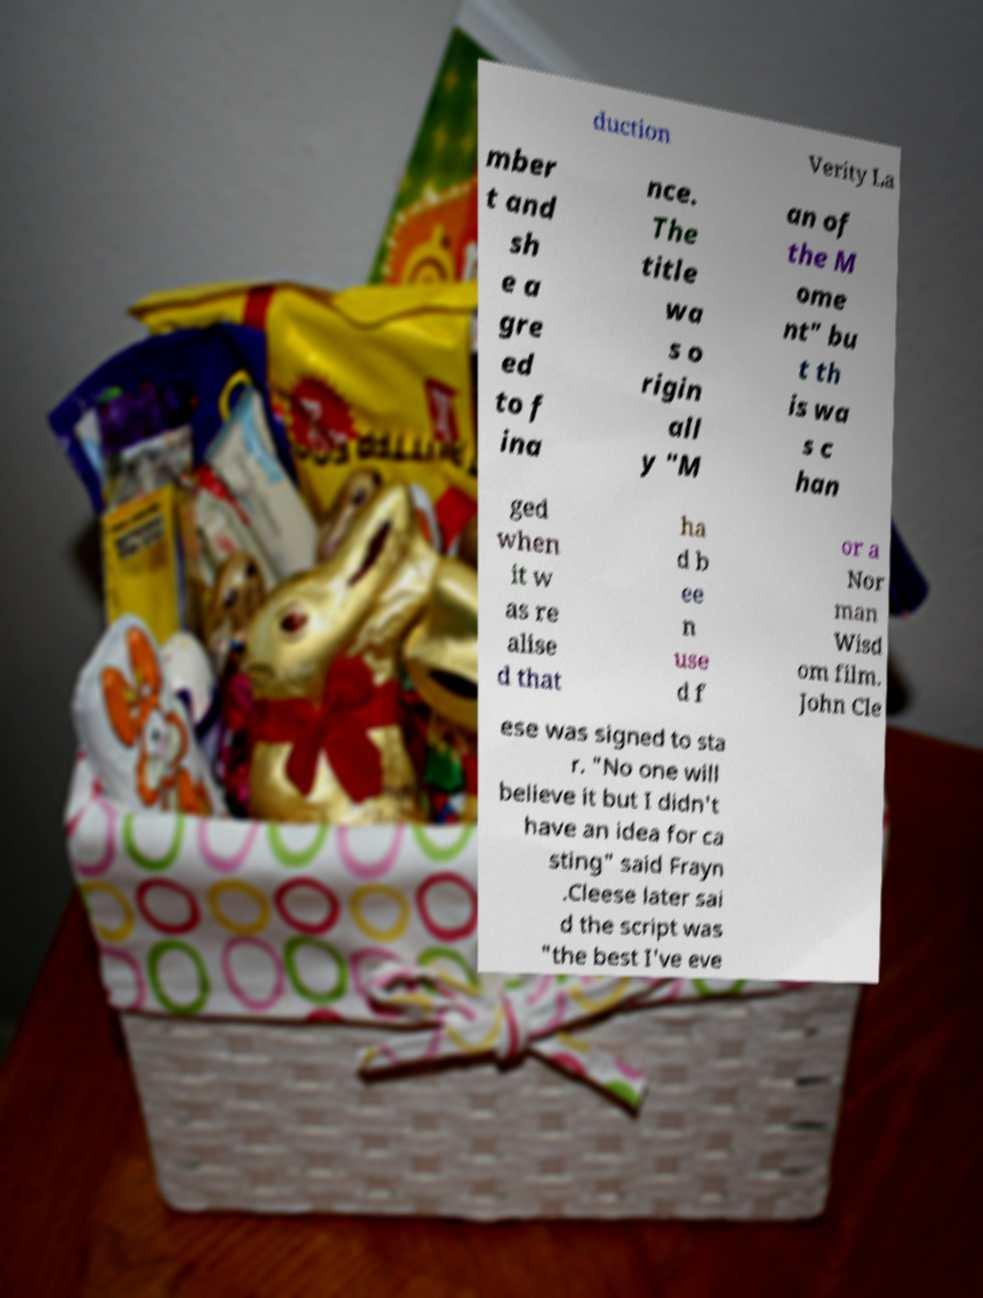I need the written content from this picture converted into text. Can you do that? duction Verity La mber t and sh e a gre ed to f ina nce. The title wa s o rigin all y "M an of the M ome nt" bu t th is wa s c han ged when it w as re alise d that ha d b ee n use d f or a Nor man Wisd om film. John Cle ese was signed to sta r. "No one will believe it but I didn't have an idea for ca sting" said Frayn .Cleese later sai d the script was "the best I've eve 